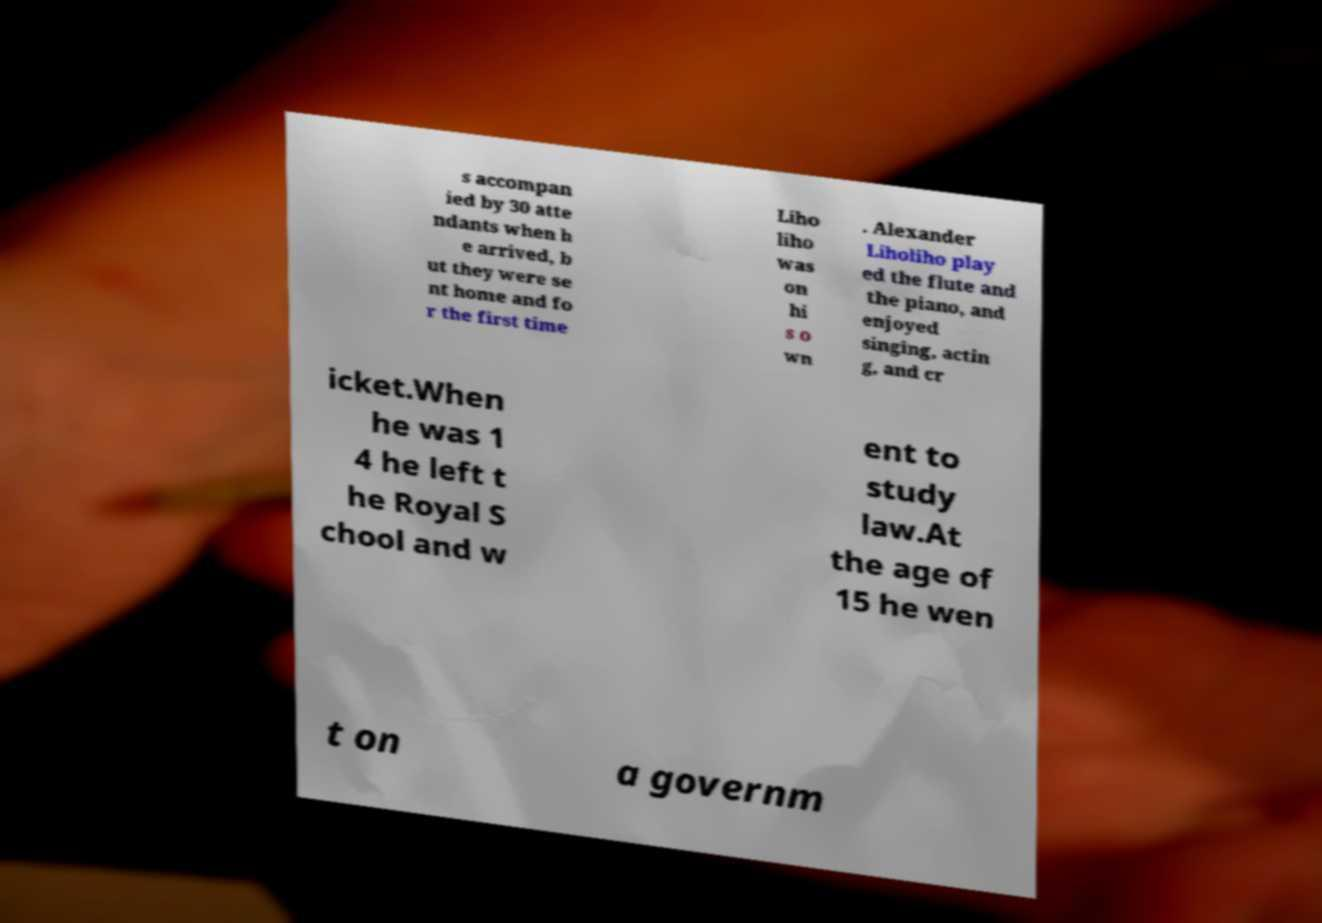What messages or text are displayed in this image? I need them in a readable, typed format. s accompan ied by 30 atte ndants when h e arrived, b ut they were se nt home and fo r the first time Liho liho was on hi s o wn . Alexander Liholiho play ed the flute and the piano, and enjoyed singing, actin g, and cr icket.When he was 1 4 he left t he Royal S chool and w ent to study law.At the age of 15 he wen t on a governm 